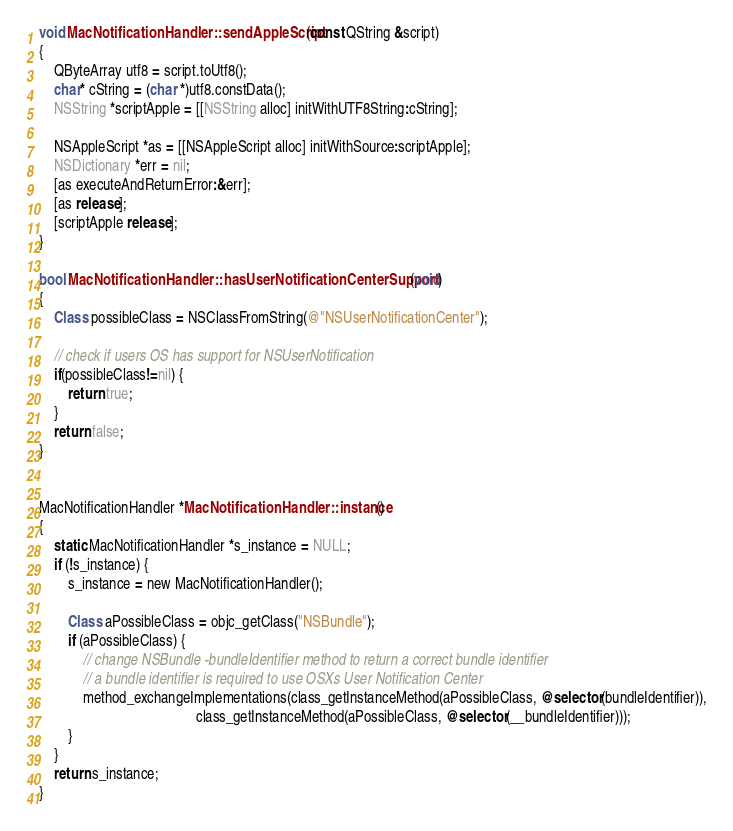<code> <loc_0><loc_0><loc_500><loc_500><_ObjectiveC_>void MacNotificationHandler::sendAppleScript(const QString &script)
{
    QByteArray utf8 = script.toUtf8();
    char* cString = (char *)utf8.constData();
    NSString *scriptApple = [[NSString alloc] initWithUTF8String:cString];

    NSAppleScript *as = [[NSAppleScript alloc] initWithSource:scriptApple];
    NSDictionary *err = nil;
    [as executeAndReturnError:&err];
    [as release];
    [scriptApple release];
}

bool MacNotificationHandler::hasUserNotificationCenterSupport(void)
{
    Class possibleClass = NSClassFromString(@"NSUserNotificationCenter");

    // check if users OS has support for NSUserNotification
    if(possibleClass!=nil) {
        return true;
    }
    return false;
}


MacNotificationHandler *MacNotificationHandler::instance()
{
    static MacNotificationHandler *s_instance = NULL;
    if (!s_instance) {
        s_instance = new MacNotificationHandler();
        
        Class aPossibleClass = objc_getClass("NSBundle");
        if (aPossibleClass) {
            // change NSBundle -bundleIdentifier method to return a correct bundle identifier
            // a bundle identifier is required to use OSXs User Notification Center
            method_exchangeImplementations(class_getInstanceMethod(aPossibleClass, @selector(bundleIdentifier)),
                                           class_getInstanceMethod(aPossibleClass, @selector(__bundleIdentifier)));
        }
    }
    return s_instance;
}
</code> 